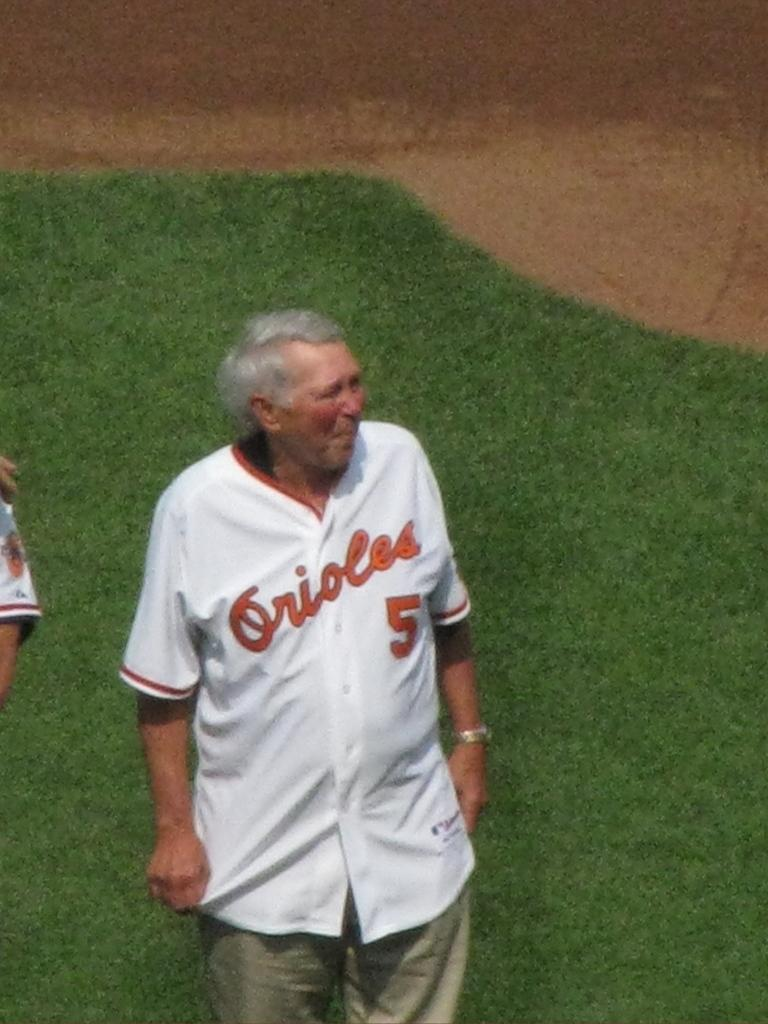<image>
Relay a brief, clear account of the picture shown. An old man standing on a ball field wearing an Orioles jersey. 